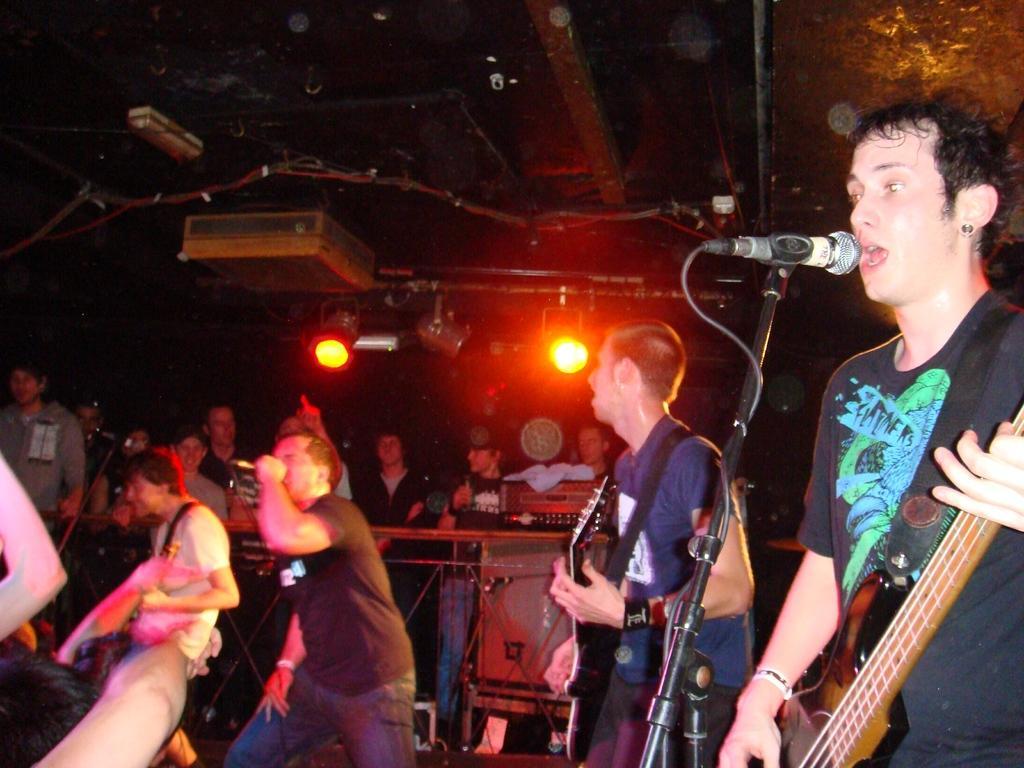Please provide a concise description of this image. In this picture we can see some people are dancing and some people are standing and singing a song through to the microphone and and they are playing a guitar back side some people are sitting and two Lights Are focusing from the backside. 